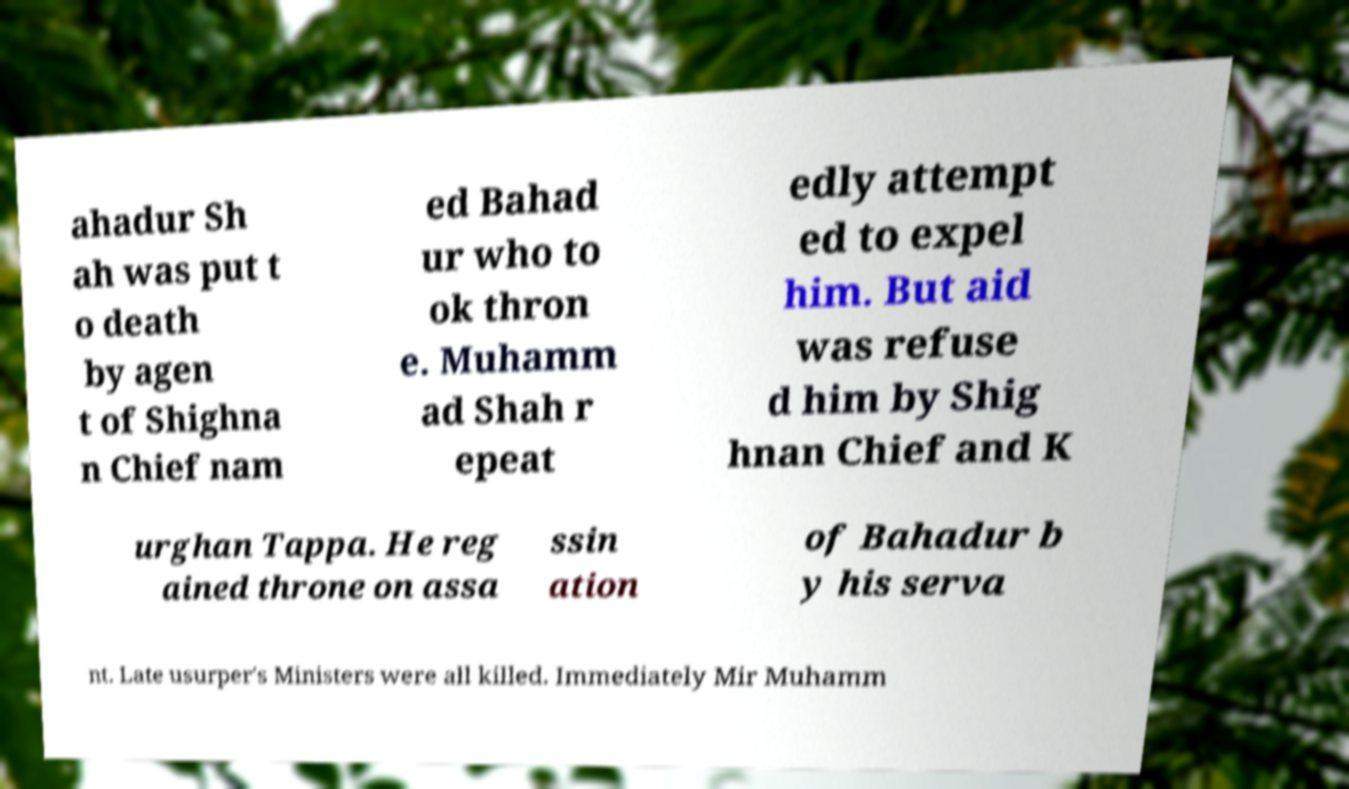Can you accurately transcribe the text from the provided image for me? ahadur Sh ah was put t o death by agen t of Shighna n Chief nam ed Bahad ur who to ok thron e. Muhamm ad Shah r epeat edly attempt ed to expel him. But aid was refuse d him by Shig hnan Chief and K urghan Tappa. He reg ained throne on assa ssin ation of Bahadur b y his serva nt. Late usurper's Ministers were all killed. Immediately Mir Muhamm 